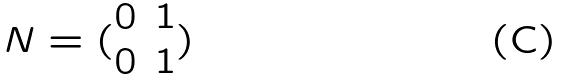<formula> <loc_0><loc_0><loc_500><loc_500>N = ( \begin{matrix} 0 & 1 \\ 0 & 1 \end{matrix} )</formula> 